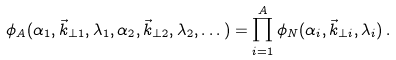Convert formula to latex. <formula><loc_0><loc_0><loc_500><loc_500>\phi _ { A } ( \alpha _ { 1 } , \vec { k } _ { \perp 1 } , \lambda _ { 1 } , \alpha _ { 2 } , \vec { k } _ { \perp 2 } , \lambda _ { 2 } , \dots ) = \prod _ { i = 1 } ^ { A } \phi _ { N } ( \alpha _ { i } , \vec { k } _ { \perp i } , \lambda _ { i } ) \, .</formula> 